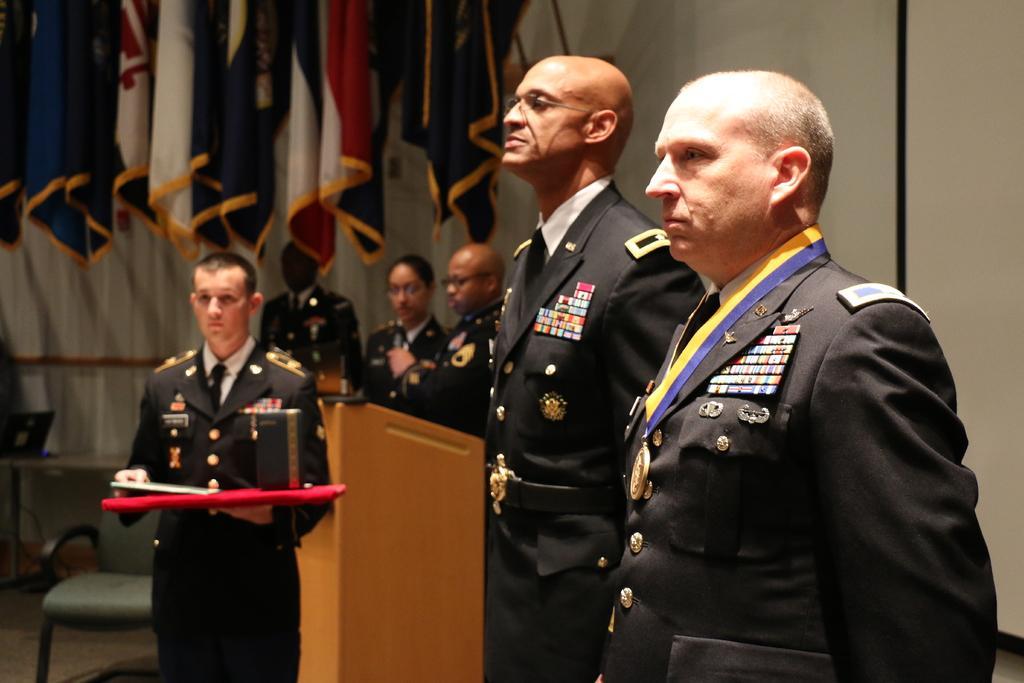In one or two sentences, can you explain what this image depicts? Here in this picture we can see a group of people standing on the floor and we can see all of the are wearing uniforms and the person on the left is holding a tray with somethings pressing on it and behind him we can see a speech desk present and on the extreme left side we can see a chair present and behind them we can see number of flag posts present. 